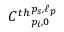Convert formula to latex. <formula><loc_0><loc_0><loc_500><loc_500>C ^ { t h _ { p _ { i } , 0 } ^ { p _ { s } , \ell _ { p } }</formula> 